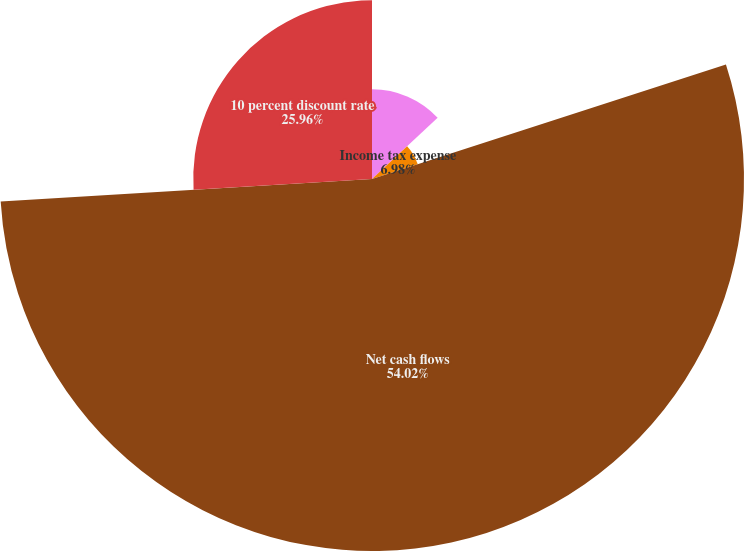<chart> <loc_0><loc_0><loc_500><loc_500><pie_chart><fcel>Development costs<fcel>Income tax expense<fcel>Net cash flows<fcel>10 percent discount rate<nl><fcel>13.04%<fcel>6.98%<fcel>54.02%<fcel>25.96%<nl></chart> 